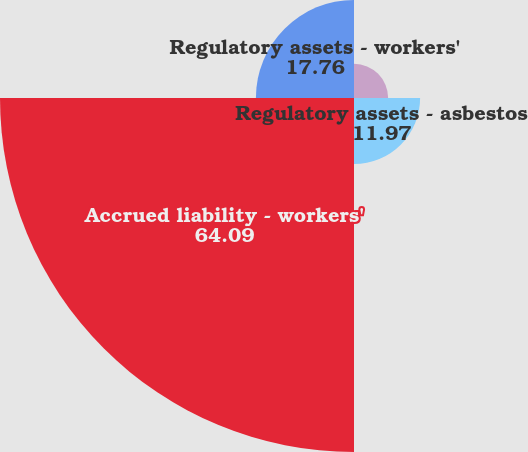Convert chart. <chart><loc_0><loc_0><loc_500><loc_500><pie_chart><fcel>Accrued liability - asbestos<fcel>Regulatory assets - asbestos<fcel>Accrued liability - workers'<fcel>Regulatory assets - workers'<nl><fcel>6.18%<fcel>11.97%<fcel>64.09%<fcel>17.76%<nl></chart> 